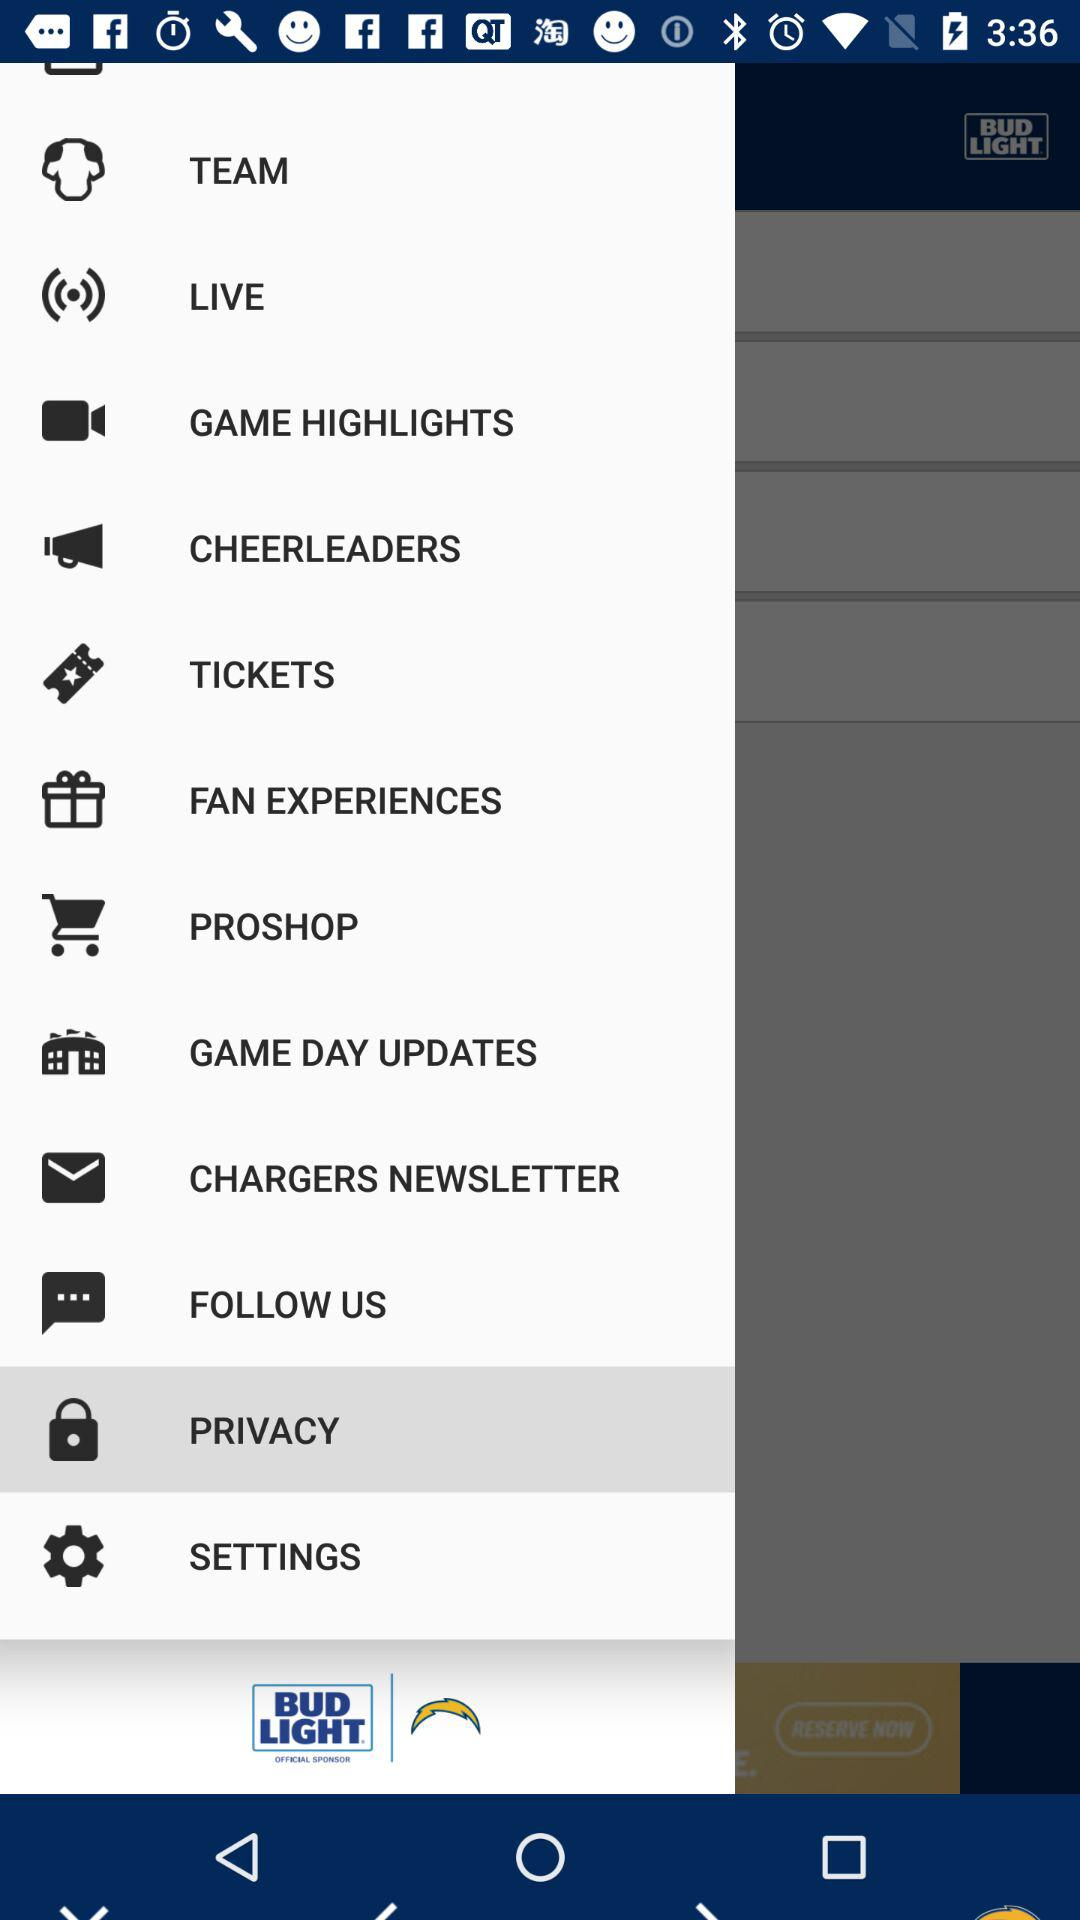Which option is selected? The selected option is "PRIVACY". 